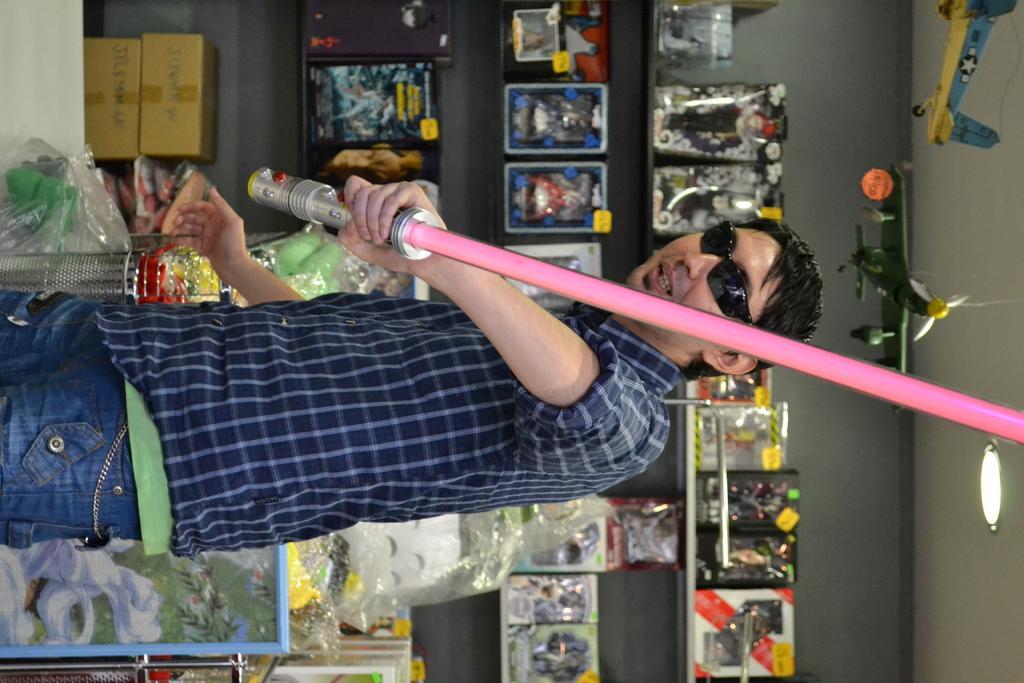Describe this image in one or two sentences. In this image we can see a man standing holding a stick. On the backside we can see a wall, ceiling lights, aeroplanes changed to the wall and some boxes placed in the shelves. 